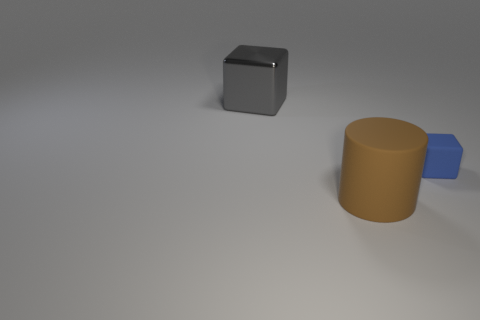Add 3 brown matte cylinders. How many objects exist? 6 Subtract all blocks. How many objects are left? 1 Subtract 0 brown spheres. How many objects are left? 3 Subtract all large brown metallic spheres. Subtract all blue things. How many objects are left? 2 Add 3 large objects. How many large objects are left? 5 Add 2 small purple rubber blocks. How many small purple rubber blocks exist? 2 